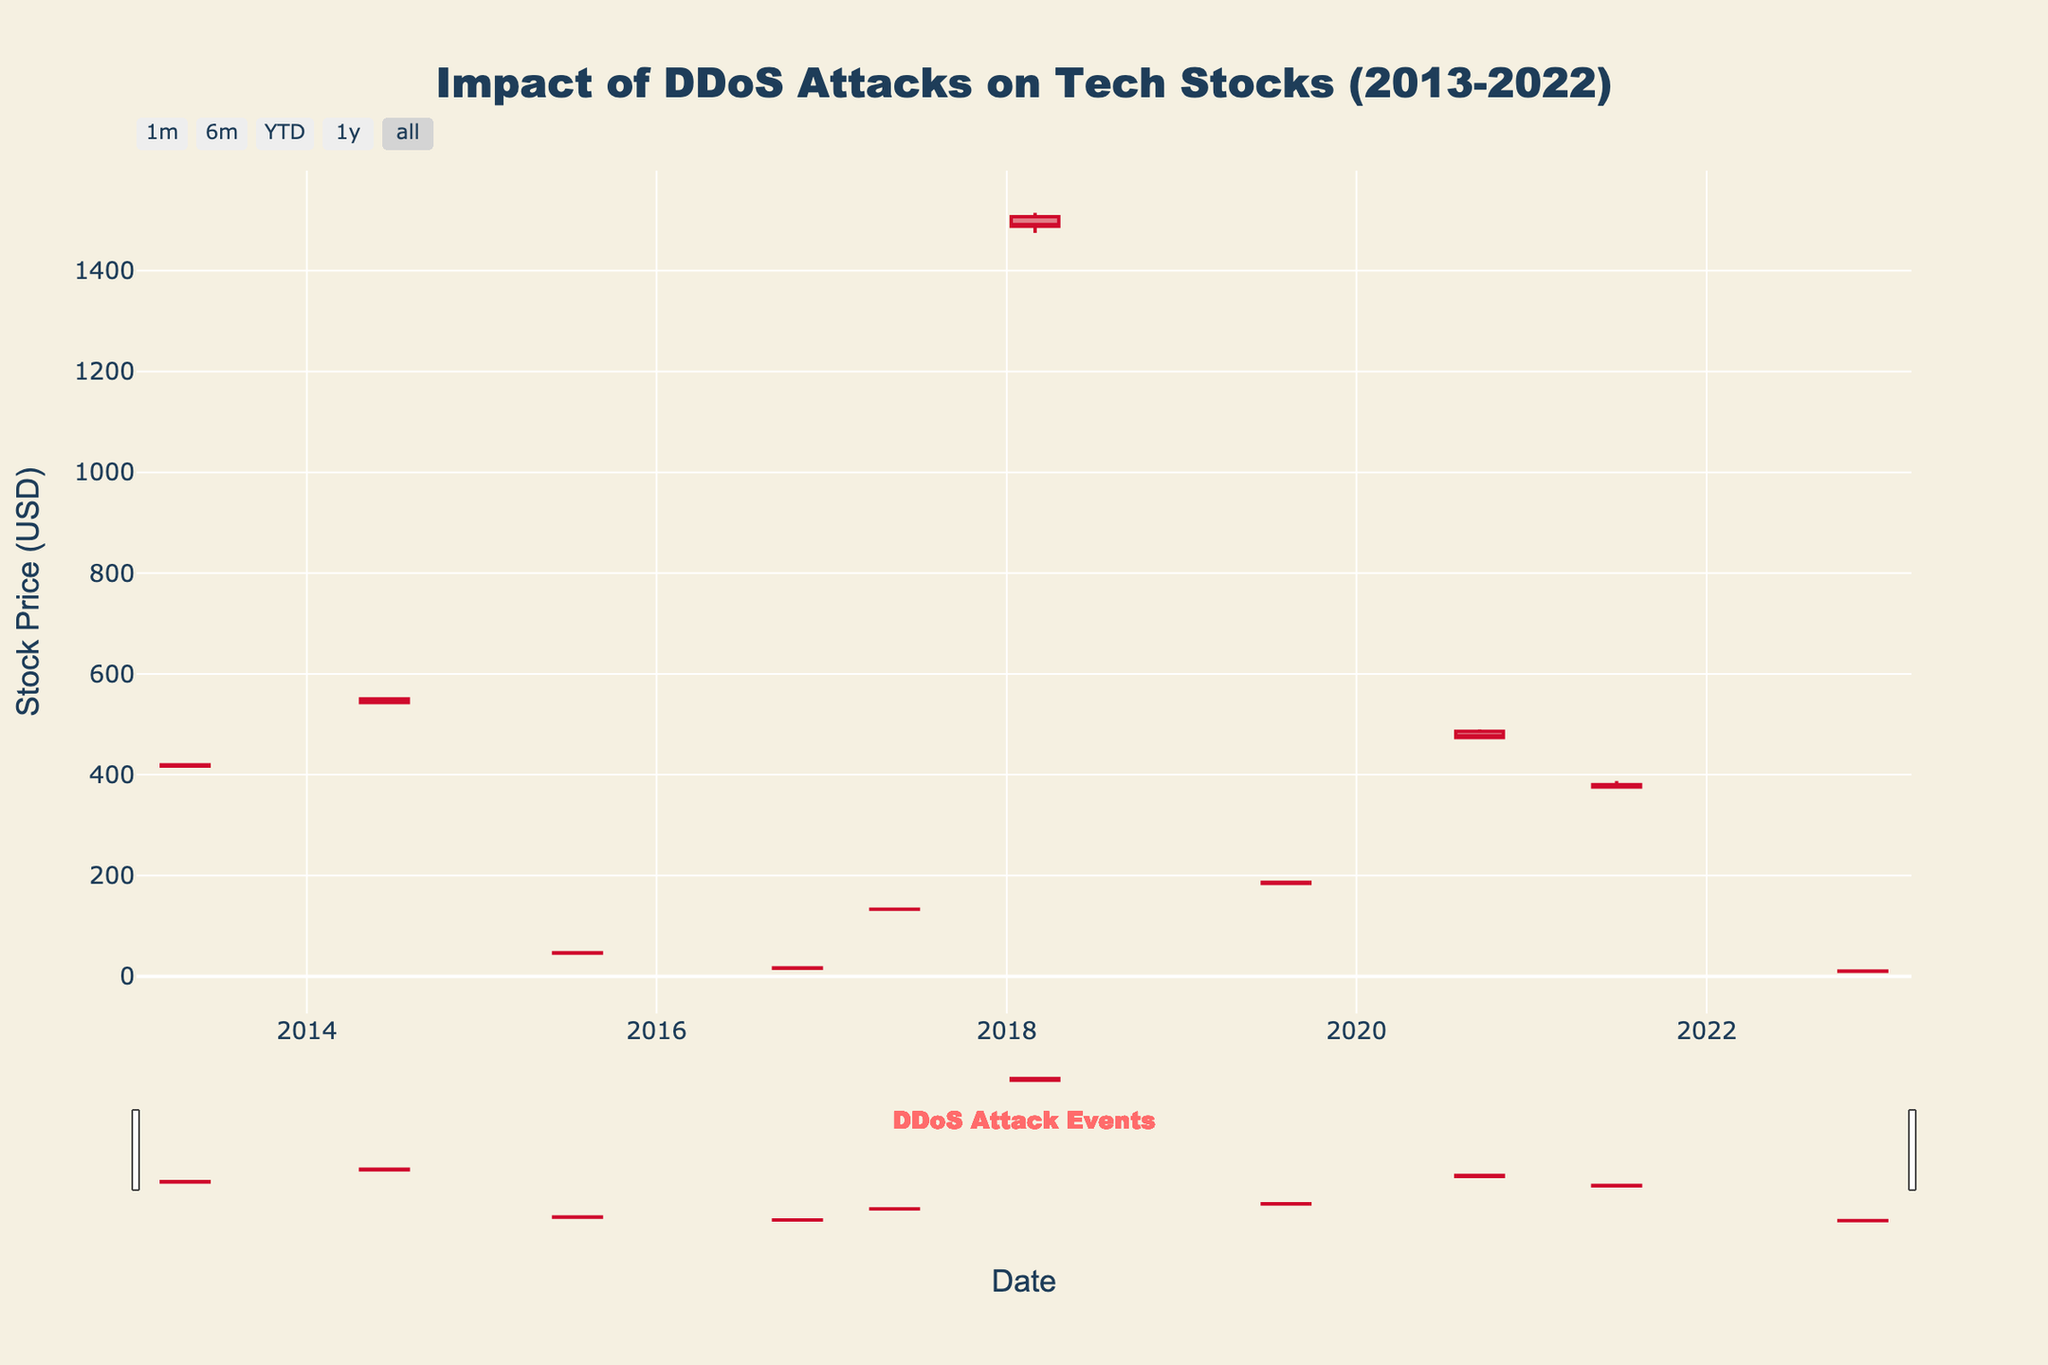What is the title of the figure? The title of the figure is displayed prominently at the top and usually summarizes what the plot is about. Here, it indicates the topic related to DDoS attacks on tech stocks over a period.
Answer: Impact of DDoS Attacks on Tech Stocks (2013-2022) How many tech companies experienced DDoS attacks according to the figure? The number of data points in the chart represents the events of DDoS attacks on different companies. Each event is annotated.
Answer: 10 Which company's stock had the highest closing price on the day of the DDoS attack? To determine this, look at the 'Close' price for each annotated event. Compare to identify the highest value.
Answer: Amazon.com Inc What was the common volume range of the stocks on DDoS attack days? The volume for each event is given in the dataset. By reviewing these values, identify the common range. Most volumes fall between 4 million and 12 million shares.
Answer: Between 4 million and 12 million shares Which company's stock experienced the largest drop in price due to a DDoS attack? This requires comparing the difference between the 'High' and 'Low' prices for each company on the DDoS attack day. The largest difference indicates the largest drop. In the case of Twitter Inc., the drop was significant.
Answer: Twitter Inc What was the date of the DDoS attack on Microsoft Corp.? Each event date corresponds with a specific company. To find this information, look for Microsoft Corp. in the list.
Answer: 2015-07-20 How did the stock price of Snap Inc. move on the day of the DDoS attack? Analyze the Open, High, Low, and Close prices for Snap Inc. to understand the stock movement on the attack date.
Answer: Open: $10.24, High: $10.76, Low: $9.80, Close: $10.05 Compare the closing price of Google Inc. and Facebook Inc. on their respective DDoS attack days. Which one closed higher? Check the 'Close' prices for Google Inc. and Facebook Inc. Compare these values directly.
Answer: Google Inc What is the trend of the stock price on the day of the DDoS attack for Netflix Inc.? Evaluate the Open, High, Low, and Close prices to identify the stock trend. For Netflix Inc., the trend was downward as it opened higher and closed lower.
Answer: Downward From the data provided, identify if there is any month that repeats more often across multiple years for DDoS attacks on tech companies? Reviewing the dates to find any recurring months can highlight a pattern. "July" or "October" tend to repeat in different years.
Answer: No clear dominant month 